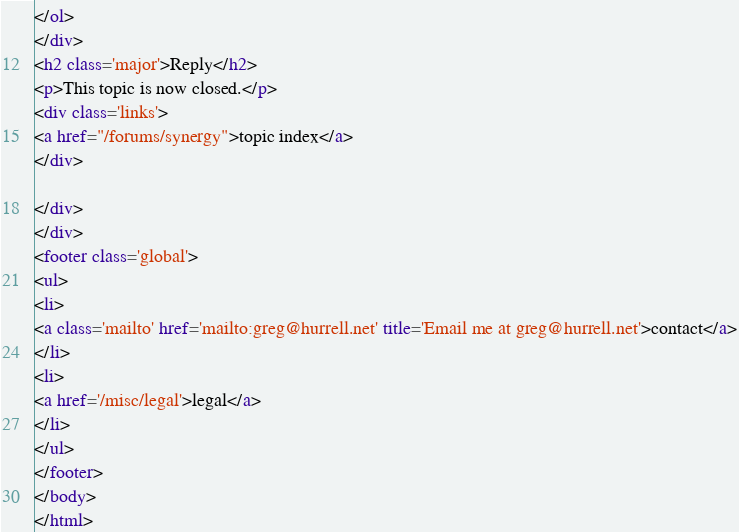<code> <loc_0><loc_0><loc_500><loc_500><_HTML_>
</ol>
</div>
<h2 class='major'>Reply</h2>
<p>This topic is now closed.</p>
<div class='links'>
<a href="/forums/synergy">topic index</a>
</div>

</div>
</div>
<footer class='global'>
<ul>
<li>
<a class='mailto' href='mailto:greg@hurrell.net' title='Email me at greg@hurrell.net'>contact</a>
</li>
<li>
<a href='/misc/legal'>legal</a>
</li>
</ul>
</footer>
</body>
</html>
</code> 